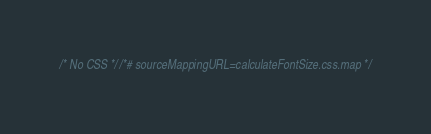<code> <loc_0><loc_0><loc_500><loc_500><_CSS_>/* No CSS *//*# sourceMappingURL=calculateFontSize.css.map */</code> 